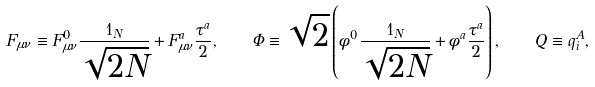Convert formula to latex. <formula><loc_0><loc_0><loc_500><loc_500>F _ { \mu \nu } \equiv F ^ { 0 } _ { \mu \nu } \frac { { 1 } _ { N } } { \sqrt { 2 N } } + F ^ { a } _ { \mu \nu } \frac { \tau ^ { a } } { 2 } , \quad \Phi \equiv \sqrt { 2 } \left ( \phi ^ { 0 } \frac { { 1 } _ { N } } { \sqrt { 2 N } } + \phi ^ { a } \frac { \tau ^ { a } } { 2 } \right ) , \quad Q \equiv q _ { i } ^ { A } ,</formula> 